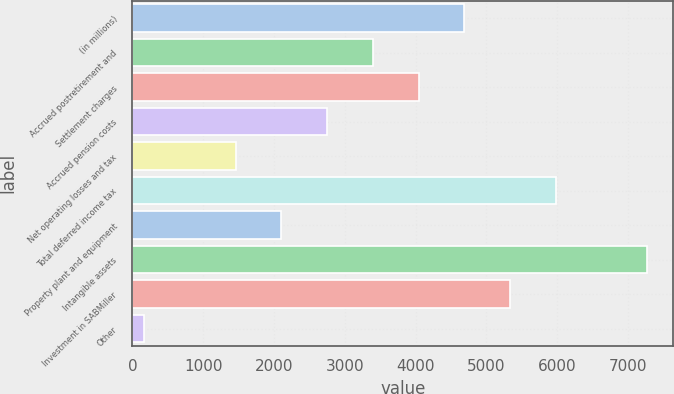Convert chart to OTSL. <chart><loc_0><loc_0><loc_500><loc_500><bar_chart><fcel>(in millions)<fcel>Accrued postretirement and<fcel>Settlement charges<fcel>Accrued pension costs<fcel>Net operating losses and tax<fcel>Total deferred income tax<fcel>Property plant and equipment<fcel>Intangible assets<fcel>Investment in SABMiller<fcel>Other<nl><fcel>4688<fcel>3396<fcel>4042<fcel>2750<fcel>1458<fcel>5980<fcel>2104<fcel>7272<fcel>5334<fcel>166<nl></chart> 